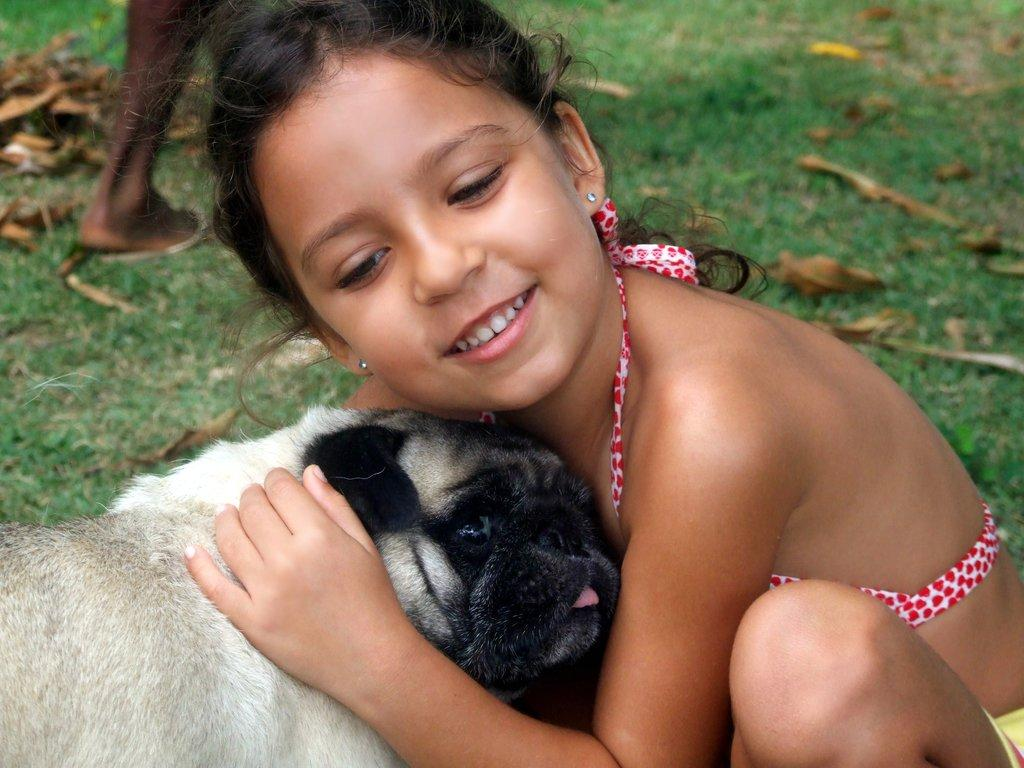Who or what can be seen in the image with the girl? There is a dog in the image with the girl. What type of surface is visible in the image? There is grass in the image. What is present on the grass? There are dry leaves on the grass. Whose legs are visible in the image? The legs of a person are visible in the image. What is the girl's opinion on the current political situation in the image? There is no indication of the girl's opinion on any political situation in the image. 